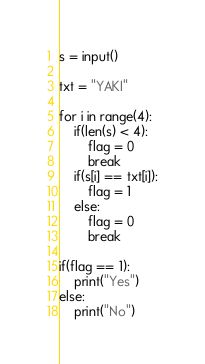<code> <loc_0><loc_0><loc_500><loc_500><_Python_>s = input()

txt = "YAKI"

for i in range(4):
    if(len(s) < 4):
        flag = 0
        break
    if(s[i] == txt[i]):
        flag = 1
    else:
        flag = 0
        break

if(flag == 1):
    print("Yes")
else:
    print("No")</code> 